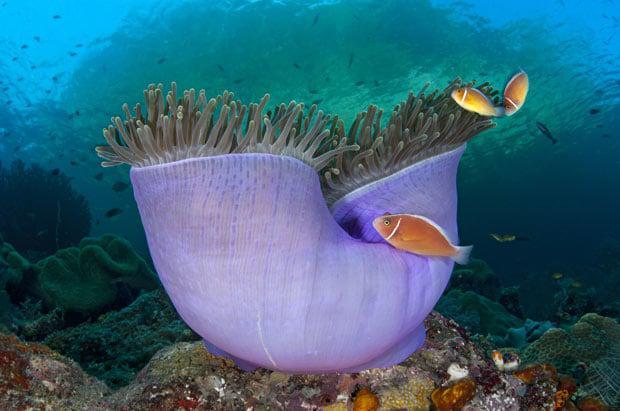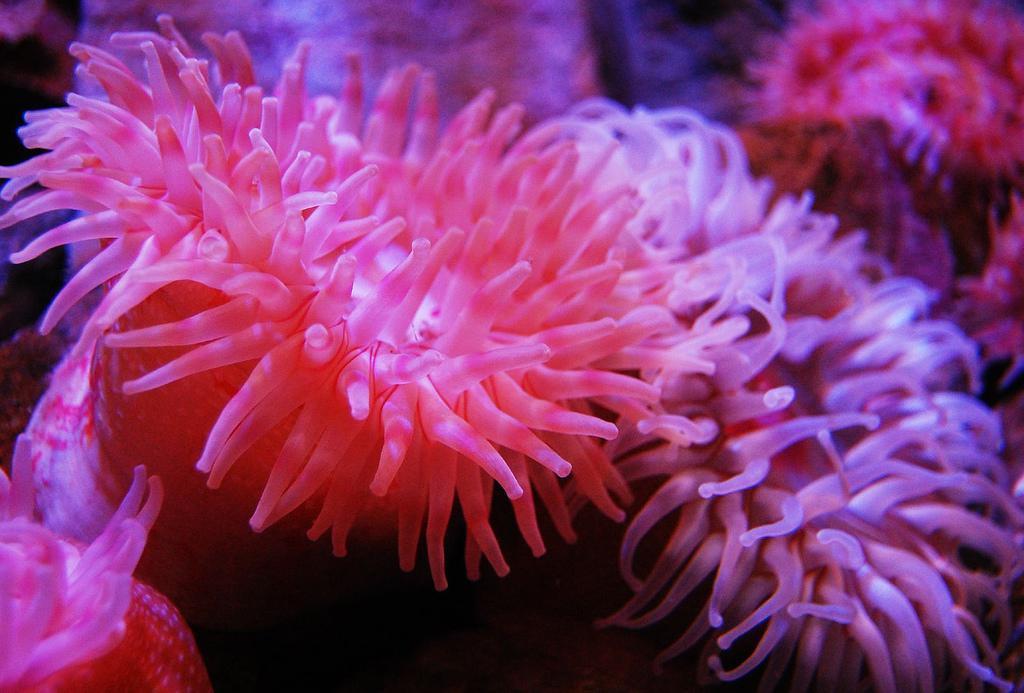The first image is the image on the left, the second image is the image on the right. For the images displayed, is the sentence "There are fish hiding inside the anemone." factually correct? Answer yes or no. No. The first image is the image on the left, the second image is the image on the right. Assess this claim about the two images: "In there water there are at least 5 corral pieces with two tone colored arms.". Correct or not? Answer yes or no. No. 